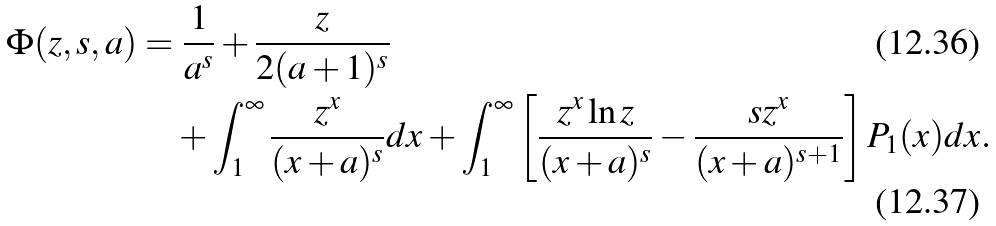<formula> <loc_0><loc_0><loc_500><loc_500>\Phi ( z , s , a ) & = \frac { 1 } { a ^ { s } } + \frac { z } { 2 ( a + 1 ) ^ { s } } \\ & \quad + \int _ { 1 } ^ { \infty } \frac { z ^ { x } } { ( x + a ) ^ { s } } d x + \int _ { 1 } ^ { \infty } \left [ \frac { z ^ { x } \ln z } { ( x + a ) ^ { s } } - \frac { s z ^ { x } } { ( x + a ) ^ { s + 1 } } \right ] P _ { 1 } ( x ) d x .</formula> 